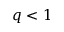<formula> <loc_0><loc_0><loc_500><loc_500>q < 1</formula> 